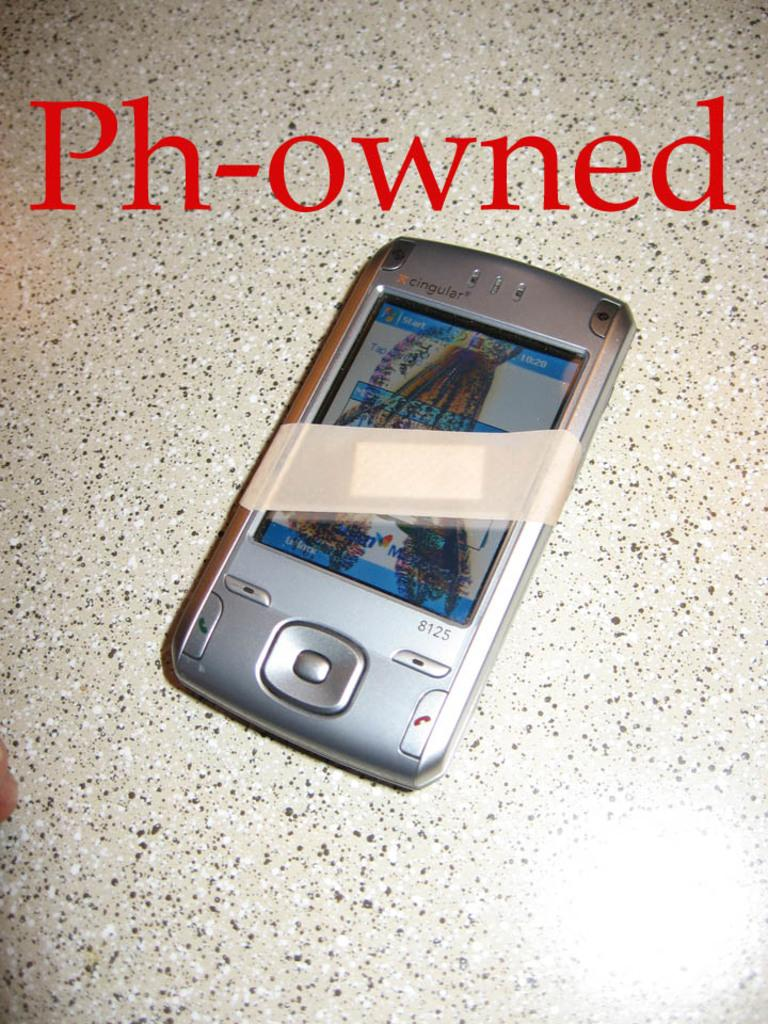<image>
Present a compact description of the photo's key features. a bandaged phone with the word ph-owned above it 